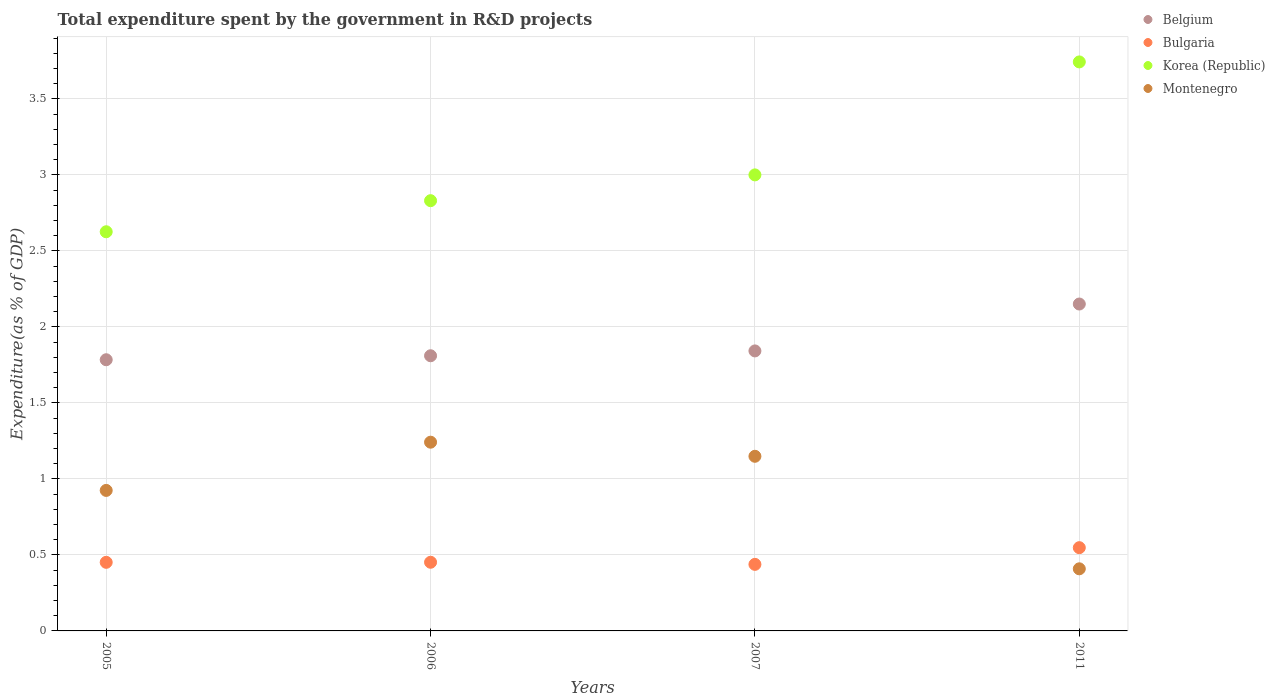Is the number of dotlines equal to the number of legend labels?
Offer a terse response. Yes. What is the total expenditure spent by the government in R&D projects in Montenegro in 2011?
Provide a short and direct response. 0.41. Across all years, what is the maximum total expenditure spent by the government in R&D projects in Belgium?
Provide a short and direct response. 2.15. Across all years, what is the minimum total expenditure spent by the government in R&D projects in Bulgaria?
Provide a short and direct response. 0.44. In which year was the total expenditure spent by the government in R&D projects in Bulgaria maximum?
Give a very brief answer. 2011. In which year was the total expenditure spent by the government in R&D projects in Korea (Republic) minimum?
Ensure brevity in your answer.  2005. What is the total total expenditure spent by the government in R&D projects in Bulgaria in the graph?
Offer a terse response. 1.89. What is the difference between the total expenditure spent by the government in R&D projects in Korea (Republic) in 2005 and that in 2011?
Give a very brief answer. -1.12. What is the difference between the total expenditure spent by the government in R&D projects in Montenegro in 2011 and the total expenditure spent by the government in R&D projects in Bulgaria in 2007?
Your answer should be very brief. -0.03. What is the average total expenditure spent by the government in R&D projects in Belgium per year?
Give a very brief answer. 1.9. In the year 2006, what is the difference between the total expenditure spent by the government in R&D projects in Montenegro and total expenditure spent by the government in R&D projects in Korea (Republic)?
Provide a succinct answer. -1.59. In how many years, is the total expenditure spent by the government in R&D projects in Bulgaria greater than 0.7 %?
Give a very brief answer. 0. What is the ratio of the total expenditure spent by the government in R&D projects in Korea (Republic) in 2006 to that in 2007?
Provide a short and direct response. 0.94. Is the total expenditure spent by the government in R&D projects in Bulgaria in 2005 less than that in 2007?
Make the answer very short. No. What is the difference between the highest and the second highest total expenditure spent by the government in R&D projects in Belgium?
Your answer should be very brief. 0.31. What is the difference between the highest and the lowest total expenditure spent by the government in R&D projects in Montenegro?
Offer a very short reply. 0.83. In how many years, is the total expenditure spent by the government in R&D projects in Bulgaria greater than the average total expenditure spent by the government in R&D projects in Bulgaria taken over all years?
Your answer should be very brief. 1. Is it the case that in every year, the sum of the total expenditure spent by the government in R&D projects in Korea (Republic) and total expenditure spent by the government in R&D projects in Bulgaria  is greater than the sum of total expenditure spent by the government in R&D projects in Montenegro and total expenditure spent by the government in R&D projects in Belgium?
Offer a very short reply. No. Is it the case that in every year, the sum of the total expenditure spent by the government in R&D projects in Montenegro and total expenditure spent by the government in R&D projects in Bulgaria  is greater than the total expenditure spent by the government in R&D projects in Korea (Republic)?
Keep it short and to the point. No. Does the total expenditure spent by the government in R&D projects in Bulgaria monotonically increase over the years?
Your answer should be very brief. No. How many years are there in the graph?
Make the answer very short. 4. What is the difference between two consecutive major ticks on the Y-axis?
Make the answer very short. 0.5. Are the values on the major ticks of Y-axis written in scientific E-notation?
Your answer should be very brief. No. Does the graph contain any zero values?
Your answer should be compact. No. How many legend labels are there?
Ensure brevity in your answer.  4. How are the legend labels stacked?
Provide a succinct answer. Vertical. What is the title of the graph?
Provide a succinct answer. Total expenditure spent by the government in R&D projects. Does "Euro area" appear as one of the legend labels in the graph?
Make the answer very short. No. What is the label or title of the X-axis?
Your answer should be compact. Years. What is the label or title of the Y-axis?
Provide a short and direct response. Expenditure(as % of GDP). What is the Expenditure(as % of GDP) in Belgium in 2005?
Provide a short and direct response. 1.78. What is the Expenditure(as % of GDP) in Bulgaria in 2005?
Make the answer very short. 0.45. What is the Expenditure(as % of GDP) in Korea (Republic) in 2005?
Make the answer very short. 2.63. What is the Expenditure(as % of GDP) in Montenegro in 2005?
Keep it short and to the point. 0.92. What is the Expenditure(as % of GDP) in Belgium in 2006?
Your answer should be very brief. 1.81. What is the Expenditure(as % of GDP) in Bulgaria in 2006?
Your answer should be compact. 0.45. What is the Expenditure(as % of GDP) in Korea (Republic) in 2006?
Your response must be concise. 2.83. What is the Expenditure(as % of GDP) of Montenegro in 2006?
Your answer should be very brief. 1.24. What is the Expenditure(as % of GDP) of Belgium in 2007?
Your answer should be compact. 1.84. What is the Expenditure(as % of GDP) of Bulgaria in 2007?
Ensure brevity in your answer.  0.44. What is the Expenditure(as % of GDP) in Korea (Republic) in 2007?
Your response must be concise. 3. What is the Expenditure(as % of GDP) of Montenegro in 2007?
Provide a succinct answer. 1.15. What is the Expenditure(as % of GDP) in Belgium in 2011?
Make the answer very short. 2.15. What is the Expenditure(as % of GDP) in Bulgaria in 2011?
Your answer should be very brief. 0.55. What is the Expenditure(as % of GDP) in Korea (Republic) in 2011?
Provide a short and direct response. 3.74. What is the Expenditure(as % of GDP) in Montenegro in 2011?
Keep it short and to the point. 0.41. Across all years, what is the maximum Expenditure(as % of GDP) of Belgium?
Provide a succinct answer. 2.15. Across all years, what is the maximum Expenditure(as % of GDP) in Bulgaria?
Provide a succinct answer. 0.55. Across all years, what is the maximum Expenditure(as % of GDP) of Korea (Republic)?
Your answer should be very brief. 3.74. Across all years, what is the maximum Expenditure(as % of GDP) in Montenegro?
Give a very brief answer. 1.24. Across all years, what is the minimum Expenditure(as % of GDP) of Belgium?
Provide a succinct answer. 1.78. Across all years, what is the minimum Expenditure(as % of GDP) of Bulgaria?
Your answer should be compact. 0.44. Across all years, what is the minimum Expenditure(as % of GDP) of Korea (Republic)?
Your response must be concise. 2.63. Across all years, what is the minimum Expenditure(as % of GDP) of Montenegro?
Make the answer very short. 0.41. What is the total Expenditure(as % of GDP) of Belgium in the graph?
Your answer should be very brief. 7.59. What is the total Expenditure(as % of GDP) of Bulgaria in the graph?
Give a very brief answer. 1.89. What is the total Expenditure(as % of GDP) in Korea (Republic) in the graph?
Your answer should be compact. 12.2. What is the total Expenditure(as % of GDP) in Montenegro in the graph?
Make the answer very short. 3.72. What is the difference between the Expenditure(as % of GDP) in Belgium in 2005 and that in 2006?
Offer a very short reply. -0.03. What is the difference between the Expenditure(as % of GDP) in Bulgaria in 2005 and that in 2006?
Offer a very short reply. -0. What is the difference between the Expenditure(as % of GDP) of Korea (Republic) in 2005 and that in 2006?
Give a very brief answer. -0.2. What is the difference between the Expenditure(as % of GDP) of Montenegro in 2005 and that in 2006?
Provide a short and direct response. -0.32. What is the difference between the Expenditure(as % of GDP) in Belgium in 2005 and that in 2007?
Your answer should be compact. -0.06. What is the difference between the Expenditure(as % of GDP) in Bulgaria in 2005 and that in 2007?
Make the answer very short. 0.01. What is the difference between the Expenditure(as % of GDP) in Korea (Republic) in 2005 and that in 2007?
Keep it short and to the point. -0.37. What is the difference between the Expenditure(as % of GDP) in Montenegro in 2005 and that in 2007?
Ensure brevity in your answer.  -0.22. What is the difference between the Expenditure(as % of GDP) of Belgium in 2005 and that in 2011?
Offer a terse response. -0.37. What is the difference between the Expenditure(as % of GDP) in Bulgaria in 2005 and that in 2011?
Offer a terse response. -0.1. What is the difference between the Expenditure(as % of GDP) in Korea (Republic) in 2005 and that in 2011?
Your answer should be compact. -1.12. What is the difference between the Expenditure(as % of GDP) in Montenegro in 2005 and that in 2011?
Offer a very short reply. 0.52. What is the difference between the Expenditure(as % of GDP) of Belgium in 2006 and that in 2007?
Your response must be concise. -0.03. What is the difference between the Expenditure(as % of GDP) in Bulgaria in 2006 and that in 2007?
Ensure brevity in your answer.  0.01. What is the difference between the Expenditure(as % of GDP) in Korea (Republic) in 2006 and that in 2007?
Provide a short and direct response. -0.17. What is the difference between the Expenditure(as % of GDP) of Montenegro in 2006 and that in 2007?
Offer a very short reply. 0.09. What is the difference between the Expenditure(as % of GDP) in Belgium in 2006 and that in 2011?
Make the answer very short. -0.34. What is the difference between the Expenditure(as % of GDP) in Bulgaria in 2006 and that in 2011?
Your answer should be very brief. -0.1. What is the difference between the Expenditure(as % of GDP) in Korea (Republic) in 2006 and that in 2011?
Your response must be concise. -0.91. What is the difference between the Expenditure(as % of GDP) of Montenegro in 2006 and that in 2011?
Your answer should be compact. 0.83. What is the difference between the Expenditure(as % of GDP) of Belgium in 2007 and that in 2011?
Make the answer very short. -0.31. What is the difference between the Expenditure(as % of GDP) of Bulgaria in 2007 and that in 2011?
Keep it short and to the point. -0.11. What is the difference between the Expenditure(as % of GDP) of Korea (Republic) in 2007 and that in 2011?
Ensure brevity in your answer.  -0.74. What is the difference between the Expenditure(as % of GDP) of Montenegro in 2007 and that in 2011?
Keep it short and to the point. 0.74. What is the difference between the Expenditure(as % of GDP) of Belgium in 2005 and the Expenditure(as % of GDP) of Bulgaria in 2006?
Ensure brevity in your answer.  1.33. What is the difference between the Expenditure(as % of GDP) of Belgium in 2005 and the Expenditure(as % of GDP) of Korea (Republic) in 2006?
Provide a succinct answer. -1.05. What is the difference between the Expenditure(as % of GDP) in Belgium in 2005 and the Expenditure(as % of GDP) in Montenegro in 2006?
Your answer should be compact. 0.54. What is the difference between the Expenditure(as % of GDP) of Bulgaria in 2005 and the Expenditure(as % of GDP) of Korea (Republic) in 2006?
Offer a terse response. -2.38. What is the difference between the Expenditure(as % of GDP) of Bulgaria in 2005 and the Expenditure(as % of GDP) of Montenegro in 2006?
Your response must be concise. -0.79. What is the difference between the Expenditure(as % of GDP) of Korea (Republic) in 2005 and the Expenditure(as % of GDP) of Montenegro in 2006?
Provide a short and direct response. 1.38. What is the difference between the Expenditure(as % of GDP) of Belgium in 2005 and the Expenditure(as % of GDP) of Bulgaria in 2007?
Keep it short and to the point. 1.35. What is the difference between the Expenditure(as % of GDP) in Belgium in 2005 and the Expenditure(as % of GDP) in Korea (Republic) in 2007?
Keep it short and to the point. -1.22. What is the difference between the Expenditure(as % of GDP) of Belgium in 2005 and the Expenditure(as % of GDP) of Montenegro in 2007?
Your response must be concise. 0.64. What is the difference between the Expenditure(as % of GDP) in Bulgaria in 2005 and the Expenditure(as % of GDP) in Korea (Republic) in 2007?
Keep it short and to the point. -2.55. What is the difference between the Expenditure(as % of GDP) of Bulgaria in 2005 and the Expenditure(as % of GDP) of Montenegro in 2007?
Your answer should be very brief. -0.7. What is the difference between the Expenditure(as % of GDP) in Korea (Republic) in 2005 and the Expenditure(as % of GDP) in Montenegro in 2007?
Offer a terse response. 1.48. What is the difference between the Expenditure(as % of GDP) in Belgium in 2005 and the Expenditure(as % of GDP) in Bulgaria in 2011?
Keep it short and to the point. 1.24. What is the difference between the Expenditure(as % of GDP) of Belgium in 2005 and the Expenditure(as % of GDP) of Korea (Republic) in 2011?
Give a very brief answer. -1.96. What is the difference between the Expenditure(as % of GDP) of Belgium in 2005 and the Expenditure(as % of GDP) of Montenegro in 2011?
Give a very brief answer. 1.38. What is the difference between the Expenditure(as % of GDP) in Bulgaria in 2005 and the Expenditure(as % of GDP) in Korea (Republic) in 2011?
Your response must be concise. -3.29. What is the difference between the Expenditure(as % of GDP) in Bulgaria in 2005 and the Expenditure(as % of GDP) in Montenegro in 2011?
Ensure brevity in your answer.  0.04. What is the difference between the Expenditure(as % of GDP) of Korea (Republic) in 2005 and the Expenditure(as % of GDP) of Montenegro in 2011?
Your response must be concise. 2.22. What is the difference between the Expenditure(as % of GDP) in Belgium in 2006 and the Expenditure(as % of GDP) in Bulgaria in 2007?
Provide a short and direct response. 1.37. What is the difference between the Expenditure(as % of GDP) in Belgium in 2006 and the Expenditure(as % of GDP) in Korea (Republic) in 2007?
Your answer should be compact. -1.19. What is the difference between the Expenditure(as % of GDP) in Belgium in 2006 and the Expenditure(as % of GDP) in Montenegro in 2007?
Give a very brief answer. 0.66. What is the difference between the Expenditure(as % of GDP) of Bulgaria in 2006 and the Expenditure(as % of GDP) of Korea (Republic) in 2007?
Make the answer very short. -2.55. What is the difference between the Expenditure(as % of GDP) in Bulgaria in 2006 and the Expenditure(as % of GDP) in Montenegro in 2007?
Provide a short and direct response. -0.7. What is the difference between the Expenditure(as % of GDP) of Korea (Republic) in 2006 and the Expenditure(as % of GDP) of Montenegro in 2007?
Offer a very short reply. 1.68. What is the difference between the Expenditure(as % of GDP) of Belgium in 2006 and the Expenditure(as % of GDP) of Bulgaria in 2011?
Your answer should be very brief. 1.26. What is the difference between the Expenditure(as % of GDP) of Belgium in 2006 and the Expenditure(as % of GDP) of Korea (Republic) in 2011?
Make the answer very short. -1.93. What is the difference between the Expenditure(as % of GDP) in Belgium in 2006 and the Expenditure(as % of GDP) in Montenegro in 2011?
Your response must be concise. 1.4. What is the difference between the Expenditure(as % of GDP) of Bulgaria in 2006 and the Expenditure(as % of GDP) of Korea (Republic) in 2011?
Your response must be concise. -3.29. What is the difference between the Expenditure(as % of GDP) in Bulgaria in 2006 and the Expenditure(as % of GDP) in Montenegro in 2011?
Keep it short and to the point. 0.04. What is the difference between the Expenditure(as % of GDP) in Korea (Republic) in 2006 and the Expenditure(as % of GDP) in Montenegro in 2011?
Make the answer very short. 2.42. What is the difference between the Expenditure(as % of GDP) in Belgium in 2007 and the Expenditure(as % of GDP) in Bulgaria in 2011?
Provide a succinct answer. 1.29. What is the difference between the Expenditure(as % of GDP) of Belgium in 2007 and the Expenditure(as % of GDP) of Korea (Republic) in 2011?
Your response must be concise. -1.9. What is the difference between the Expenditure(as % of GDP) of Belgium in 2007 and the Expenditure(as % of GDP) of Montenegro in 2011?
Your response must be concise. 1.43. What is the difference between the Expenditure(as % of GDP) of Bulgaria in 2007 and the Expenditure(as % of GDP) of Korea (Republic) in 2011?
Offer a very short reply. -3.31. What is the difference between the Expenditure(as % of GDP) of Bulgaria in 2007 and the Expenditure(as % of GDP) of Montenegro in 2011?
Your answer should be compact. 0.03. What is the difference between the Expenditure(as % of GDP) in Korea (Republic) in 2007 and the Expenditure(as % of GDP) in Montenegro in 2011?
Provide a succinct answer. 2.59. What is the average Expenditure(as % of GDP) in Belgium per year?
Ensure brevity in your answer.  1.9. What is the average Expenditure(as % of GDP) in Bulgaria per year?
Give a very brief answer. 0.47. What is the average Expenditure(as % of GDP) of Korea (Republic) per year?
Offer a very short reply. 3.05. What is the average Expenditure(as % of GDP) of Montenegro per year?
Provide a succinct answer. 0.93. In the year 2005, what is the difference between the Expenditure(as % of GDP) of Belgium and Expenditure(as % of GDP) of Bulgaria?
Ensure brevity in your answer.  1.33. In the year 2005, what is the difference between the Expenditure(as % of GDP) in Belgium and Expenditure(as % of GDP) in Korea (Republic)?
Offer a terse response. -0.84. In the year 2005, what is the difference between the Expenditure(as % of GDP) of Belgium and Expenditure(as % of GDP) of Montenegro?
Make the answer very short. 0.86. In the year 2005, what is the difference between the Expenditure(as % of GDP) in Bulgaria and Expenditure(as % of GDP) in Korea (Republic)?
Your answer should be compact. -2.17. In the year 2005, what is the difference between the Expenditure(as % of GDP) in Bulgaria and Expenditure(as % of GDP) in Montenegro?
Make the answer very short. -0.47. In the year 2005, what is the difference between the Expenditure(as % of GDP) in Korea (Republic) and Expenditure(as % of GDP) in Montenegro?
Offer a terse response. 1.7. In the year 2006, what is the difference between the Expenditure(as % of GDP) of Belgium and Expenditure(as % of GDP) of Bulgaria?
Ensure brevity in your answer.  1.36. In the year 2006, what is the difference between the Expenditure(as % of GDP) of Belgium and Expenditure(as % of GDP) of Korea (Republic)?
Provide a succinct answer. -1.02. In the year 2006, what is the difference between the Expenditure(as % of GDP) in Belgium and Expenditure(as % of GDP) in Montenegro?
Give a very brief answer. 0.57. In the year 2006, what is the difference between the Expenditure(as % of GDP) of Bulgaria and Expenditure(as % of GDP) of Korea (Republic)?
Offer a terse response. -2.38. In the year 2006, what is the difference between the Expenditure(as % of GDP) in Bulgaria and Expenditure(as % of GDP) in Montenegro?
Provide a succinct answer. -0.79. In the year 2006, what is the difference between the Expenditure(as % of GDP) of Korea (Republic) and Expenditure(as % of GDP) of Montenegro?
Provide a short and direct response. 1.59. In the year 2007, what is the difference between the Expenditure(as % of GDP) of Belgium and Expenditure(as % of GDP) of Bulgaria?
Provide a short and direct response. 1.4. In the year 2007, what is the difference between the Expenditure(as % of GDP) in Belgium and Expenditure(as % of GDP) in Korea (Republic)?
Offer a very short reply. -1.16. In the year 2007, what is the difference between the Expenditure(as % of GDP) in Belgium and Expenditure(as % of GDP) in Montenegro?
Ensure brevity in your answer.  0.69. In the year 2007, what is the difference between the Expenditure(as % of GDP) of Bulgaria and Expenditure(as % of GDP) of Korea (Republic)?
Give a very brief answer. -2.56. In the year 2007, what is the difference between the Expenditure(as % of GDP) in Bulgaria and Expenditure(as % of GDP) in Montenegro?
Keep it short and to the point. -0.71. In the year 2007, what is the difference between the Expenditure(as % of GDP) of Korea (Republic) and Expenditure(as % of GDP) of Montenegro?
Ensure brevity in your answer.  1.85. In the year 2011, what is the difference between the Expenditure(as % of GDP) of Belgium and Expenditure(as % of GDP) of Bulgaria?
Your answer should be compact. 1.6. In the year 2011, what is the difference between the Expenditure(as % of GDP) in Belgium and Expenditure(as % of GDP) in Korea (Republic)?
Your answer should be compact. -1.59. In the year 2011, what is the difference between the Expenditure(as % of GDP) in Belgium and Expenditure(as % of GDP) in Montenegro?
Make the answer very short. 1.74. In the year 2011, what is the difference between the Expenditure(as % of GDP) of Bulgaria and Expenditure(as % of GDP) of Korea (Republic)?
Offer a very short reply. -3.2. In the year 2011, what is the difference between the Expenditure(as % of GDP) in Bulgaria and Expenditure(as % of GDP) in Montenegro?
Your answer should be compact. 0.14. In the year 2011, what is the difference between the Expenditure(as % of GDP) of Korea (Republic) and Expenditure(as % of GDP) of Montenegro?
Your answer should be compact. 3.33. What is the ratio of the Expenditure(as % of GDP) in Belgium in 2005 to that in 2006?
Offer a terse response. 0.99. What is the ratio of the Expenditure(as % of GDP) in Bulgaria in 2005 to that in 2006?
Provide a short and direct response. 1. What is the ratio of the Expenditure(as % of GDP) of Korea (Republic) in 2005 to that in 2006?
Offer a terse response. 0.93. What is the ratio of the Expenditure(as % of GDP) of Montenegro in 2005 to that in 2006?
Make the answer very short. 0.74. What is the ratio of the Expenditure(as % of GDP) in Belgium in 2005 to that in 2007?
Offer a very short reply. 0.97. What is the ratio of the Expenditure(as % of GDP) in Bulgaria in 2005 to that in 2007?
Provide a short and direct response. 1.03. What is the ratio of the Expenditure(as % of GDP) of Korea (Republic) in 2005 to that in 2007?
Your response must be concise. 0.88. What is the ratio of the Expenditure(as % of GDP) in Montenegro in 2005 to that in 2007?
Your response must be concise. 0.8. What is the ratio of the Expenditure(as % of GDP) in Belgium in 2005 to that in 2011?
Your response must be concise. 0.83. What is the ratio of the Expenditure(as % of GDP) of Bulgaria in 2005 to that in 2011?
Provide a short and direct response. 0.82. What is the ratio of the Expenditure(as % of GDP) in Korea (Republic) in 2005 to that in 2011?
Ensure brevity in your answer.  0.7. What is the ratio of the Expenditure(as % of GDP) of Montenegro in 2005 to that in 2011?
Your answer should be very brief. 2.26. What is the ratio of the Expenditure(as % of GDP) in Belgium in 2006 to that in 2007?
Offer a very short reply. 0.98. What is the ratio of the Expenditure(as % of GDP) of Bulgaria in 2006 to that in 2007?
Make the answer very short. 1.03. What is the ratio of the Expenditure(as % of GDP) in Korea (Republic) in 2006 to that in 2007?
Your answer should be very brief. 0.94. What is the ratio of the Expenditure(as % of GDP) of Montenegro in 2006 to that in 2007?
Offer a very short reply. 1.08. What is the ratio of the Expenditure(as % of GDP) in Belgium in 2006 to that in 2011?
Ensure brevity in your answer.  0.84. What is the ratio of the Expenditure(as % of GDP) in Bulgaria in 2006 to that in 2011?
Your answer should be very brief. 0.82. What is the ratio of the Expenditure(as % of GDP) of Korea (Republic) in 2006 to that in 2011?
Provide a succinct answer. 0.76. What is the ratio of the Expenditure(as % of GDP) of Montenegro in 2006 to that in 2011?
Make the answer very short. 3.04. What is the ratio of the Expenditure(as % of GDP) in Belgium in 2007 to that in 2011?
Make the answer very short. 0.86. What is the ratio of the Expenditure(as % of GDP) in Bulgaria in 2007 to that in 2011?
Give a very brief answer. 0.8. What is the ratio of the Expenditure(as % of GDP) of Korea (Republic) in 2007 to that in 2011?
Offer a very short reply. 0.8. What is the ratio of the Expenditure(as % of GDP) of Montenegro in 2007 to that in 2011?
Offer a terse response. 2.81. What is the difference between the highest and the second highest Expenditure(as % of GDP) in Belgium?
Ensure brevity in your answer.  0.31. What is the difference between the highest and the second highest Expenditure(as % of GDP) of Bulgaria?
Make the answer very short. 0.1. What is the difference between the highest and the second highest Expenditure(as % of GDP) in Korea (Republic)?
Give a very brief answer. 0.74. What is the difference between the highest and the second highest Expenditure(as % of GDP) of Montenegro?
Make the answer very short. 0.09. What is the difference between the highest and the lowest Expenditure(as % of GDP) of Belgium?
Ensure brevity in your answer.  0.37. What is the difference between the highest and the lowest Expenditure(as % of GDP) of Bulgaria?
Offer a terse response. 0.11. What is the difference between the highest and the lowest Expenditure(as % of GDP) in Korea (Republic)?
Your response must be concise. 1.12. What is the difference between the highest and the lowest Expenditure(as % of GDP) in Montenegro?
Offer a very short reply. 0.83. 